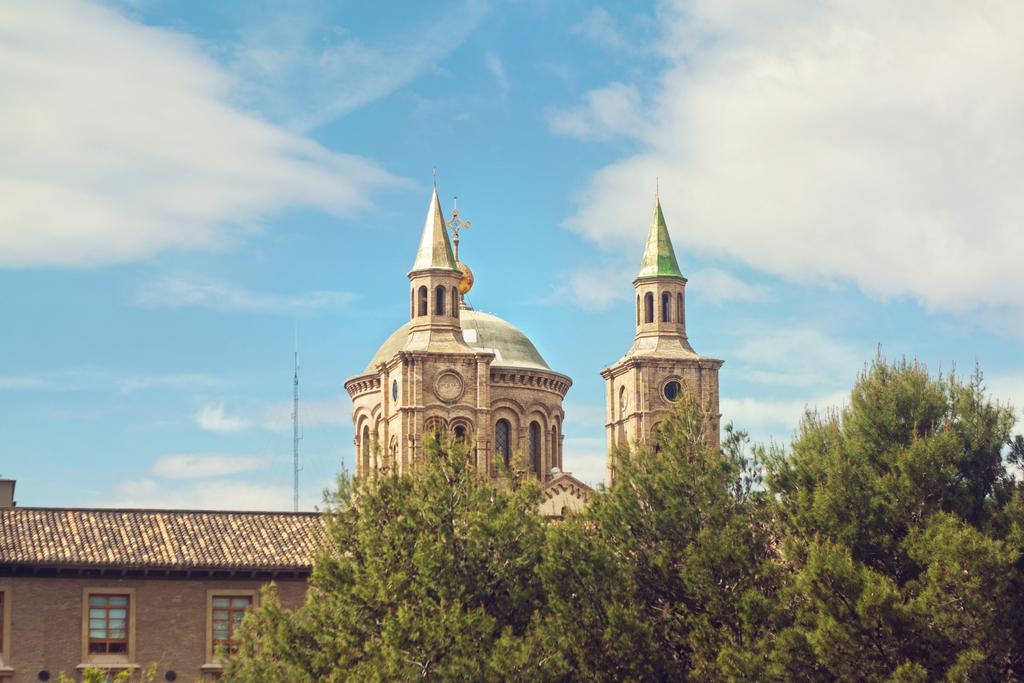Could you give a brief overview of what you see in this image? In this picture there are trees at the bottom side of the image and there is a palace in the center of the image, there are windows on it. 